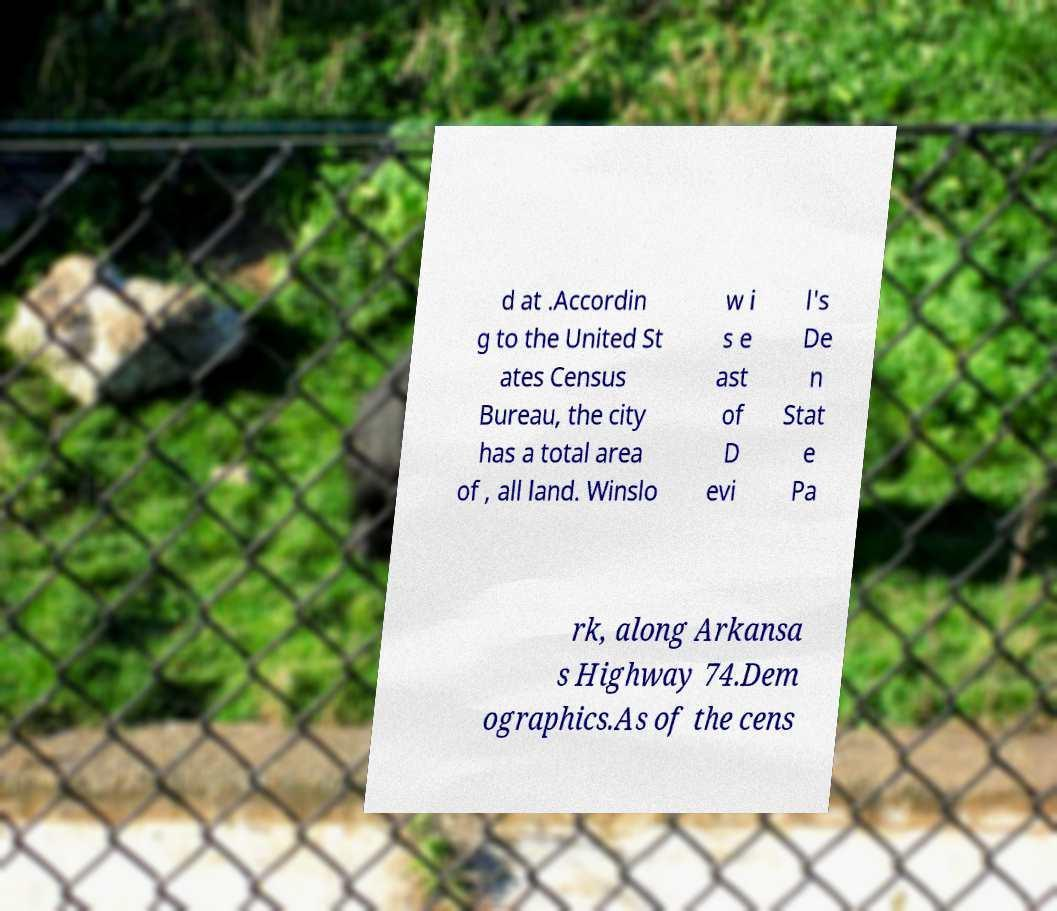Can you accurately transcribe the text from the provided image for me? d at .Accordin g to the United St ates Census Bureau, the city has a total area of , all land. Winslo w i s e ast of D evi l's De n Stat e Pa rk, along Arkansa s Highway 74.Dem ographics.As of the cens 